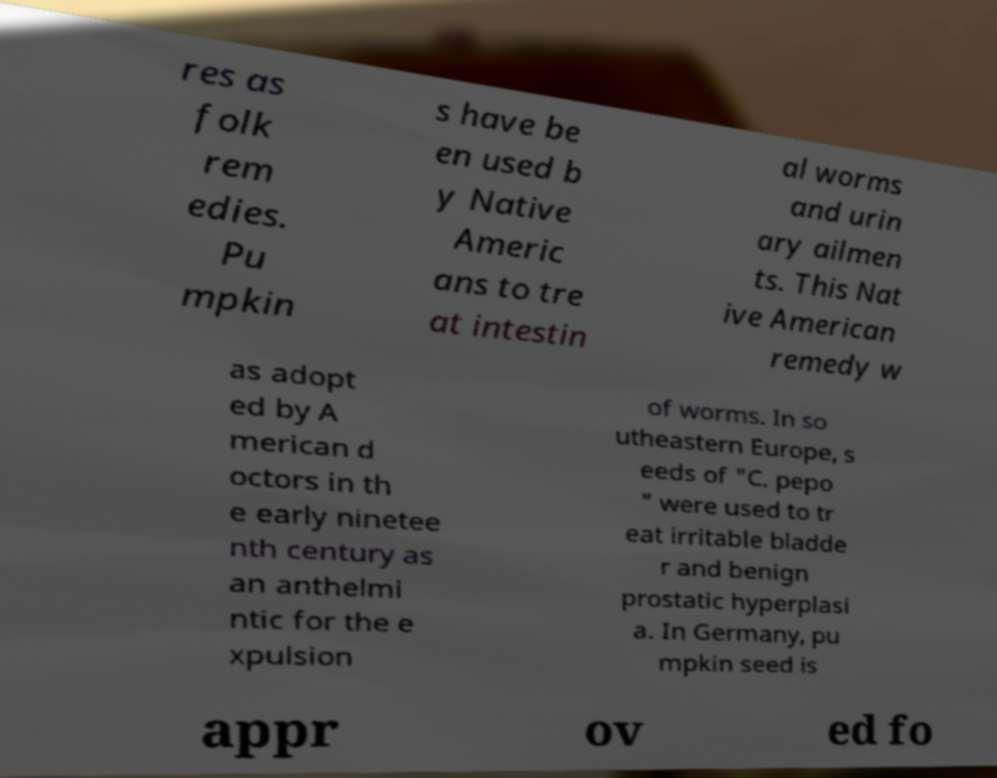There's text embedded in this image that I need extracted. Can you transcribe it verbatim? res as folk rem edies. Pu mpkin s have be en used b y Native Americ ans to tre at intestin al worms and urin ary ailmen ts. This Nat ive American remedy w as adopt ed by A merican d octors in th e early ninetee nth century as an anthelmi ntic for the e xpulsion of worms. In so utheastern Europe, s eeds of "C. pepo " were used to tr eat irritable bladde r and benign prostatic hyperplasi a. In Germany, pu mpkin seed is appr ov ed fo 